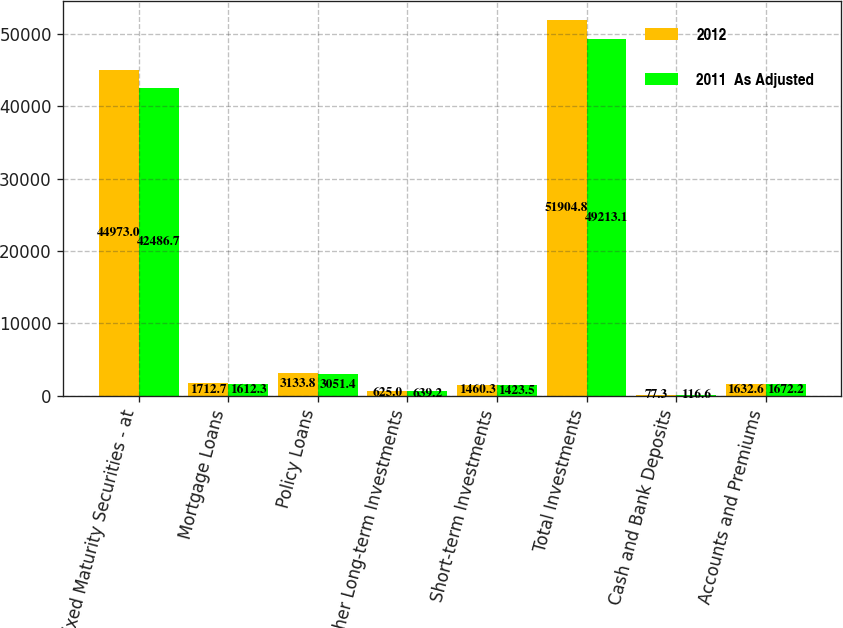Convert chart. <chart><loc_0><loc_0><loc_500><loc_500><stacked_bar_chart><ecel><fcel>Fixed Maturity Securities - at<fcel>Mortgage Loans<fcel>Policy Loans<fcel>Other Long-term Investments<fcel>Short-term Investments<fcel>Total Investments<fcel>Cash and Bank Deposits<fcel>Accounts and Premiums<nl><fcel>2012<fcel>44973<fcel>1712.7<fcel>3133.8<fcel>625<fcel>1460.3<fcel>51904.8<fcel>77.3<fcel>1632.6<nl><fcel>2011  As Adjusted<fcel>42486.7<fcel>1612.3<fcel>3051.4<fcel>639.2<fcel>1423.5<fcel>49213.1<fcel>116.6<fcel>1672.2<nl></chart> 